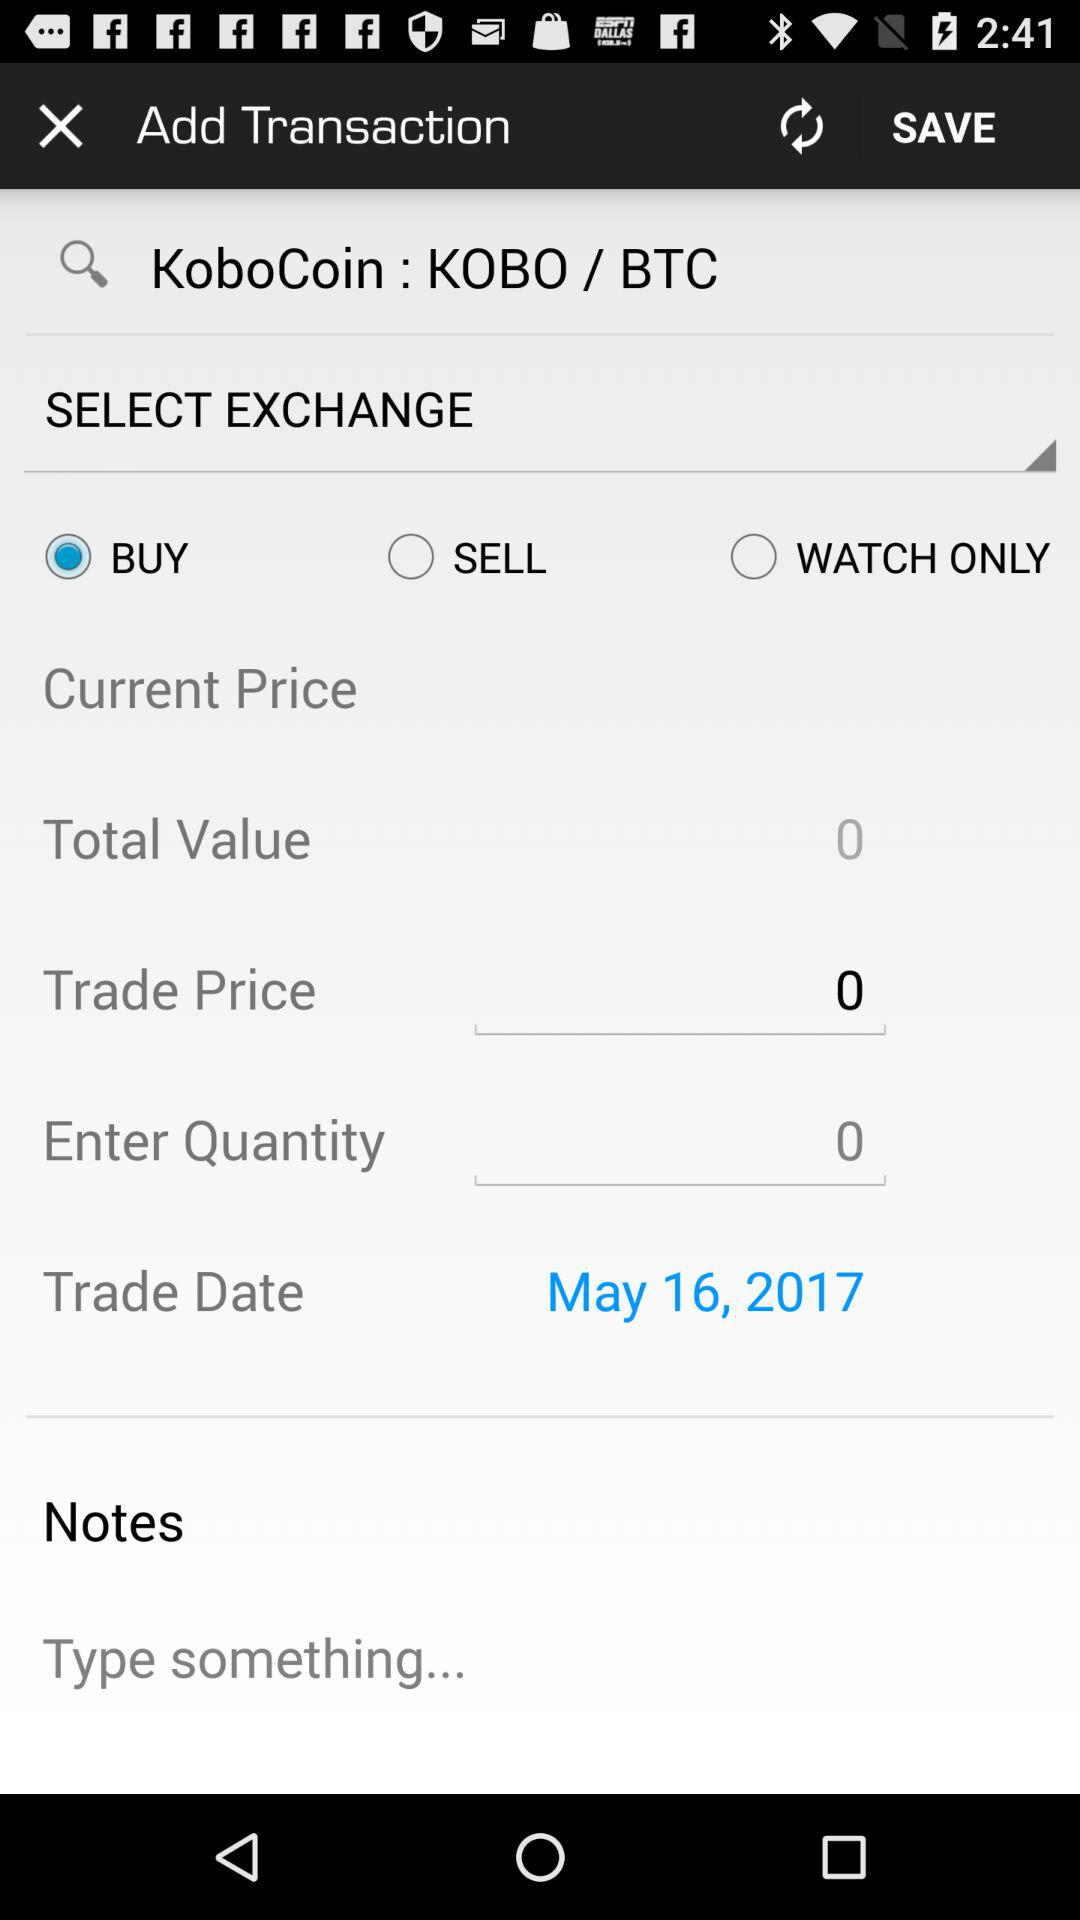Which option is selected in exchange?
When the provided information is insufficient, respond with <no answer>. <no answer> 